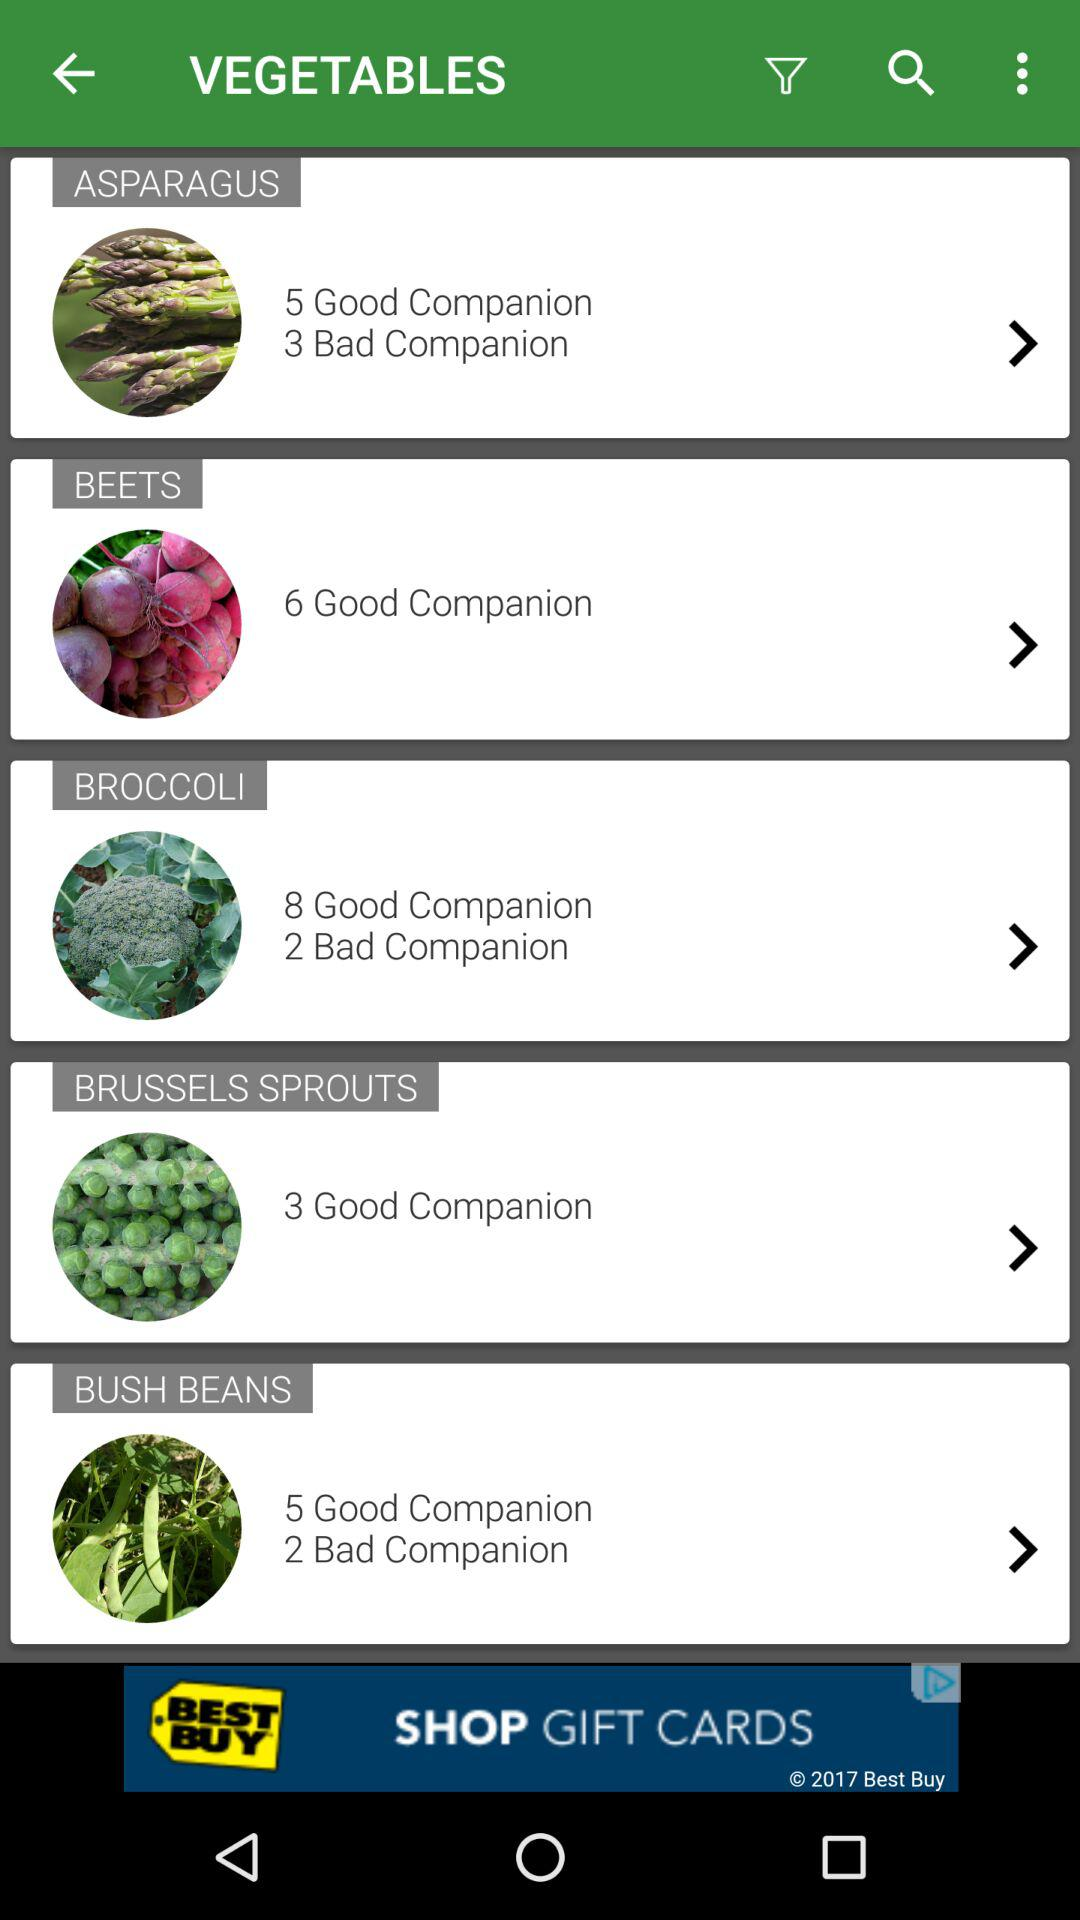Which asparagus has three bad companions?
When the provided information is insufficient, respond with <no answer>. <no answer> 